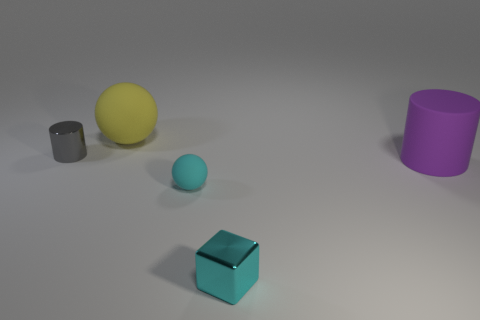Add 1 cyan metallic cylinders. How many objects exist? 6 Subtract all cubes. How many objects are left? 4 Subtract all yellow matte blocks. Subtract all yellow spheres. How many objects are left? 4 Add 3 small cyan objects. How many small cyan objects are left? 5 Add 4 big brown balls. How many big brown balls exist? 4 Subtract 1 cyan spheres. How many objects are left? 4 